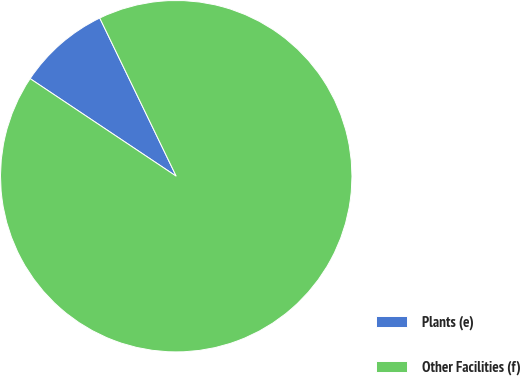Convert chart. <chart><loc_0><loc_0><loc_500><loc_500><pie_chart><fcel>Plants (e)<fcel>Other Facilities (f)<nl><fcel>8.46%<fcel>91.54%<nl></chart> 